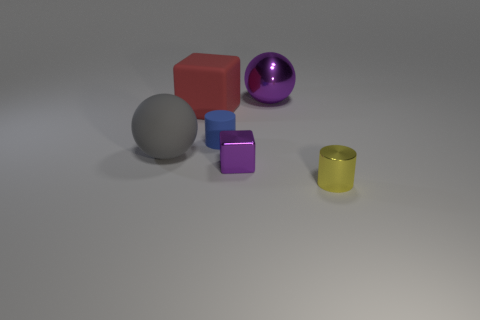Add 4 large brown cylinders. How many objects exist? 10 Subtract all blocks. How many objects are left? 4 Subtract all small red rubber things. Subtract all gray balls. How many objects are left? 5 Add 5 purple metal blocks. How many purple metal blocks are left? 6 Add 4 small purple metallic cubes. How many small purple metallic cubes exist? 5 Subtract 0 brown blocks. How many objects are left? 6 